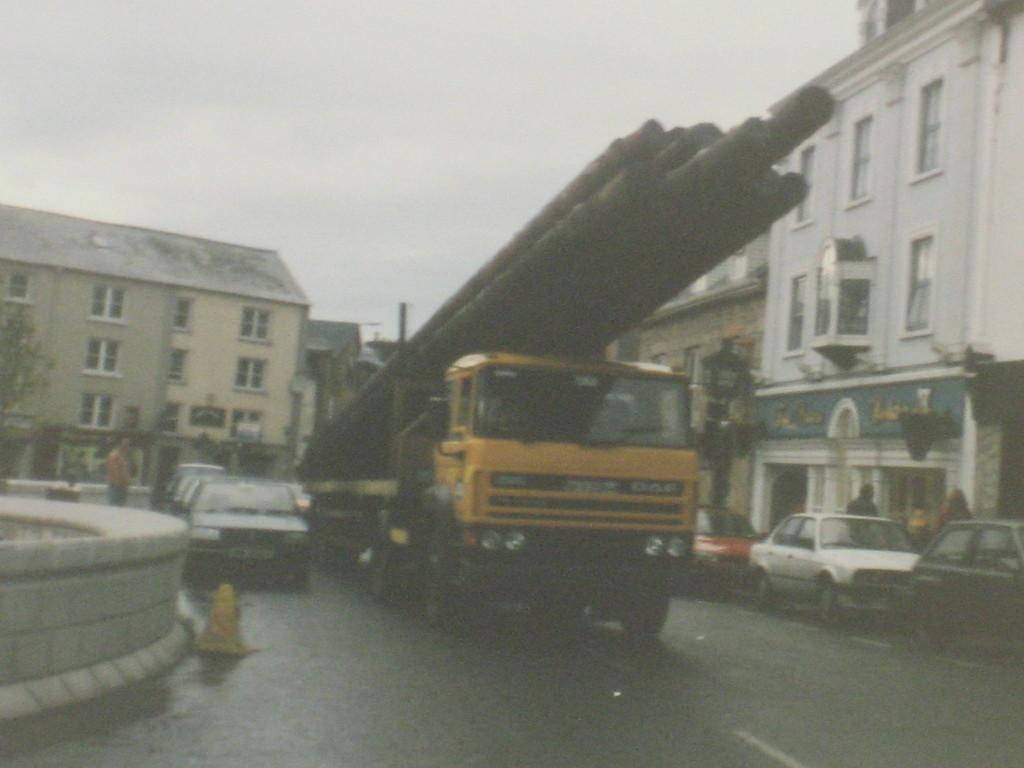Describe this image in one or two sentences. In the foreground of this image, there is a truck with long pipes in it moving on the road and also there are many vehicles moving on the road. On right side of the image, there are building. In the background, there is a building, pole, trees and the sky. 